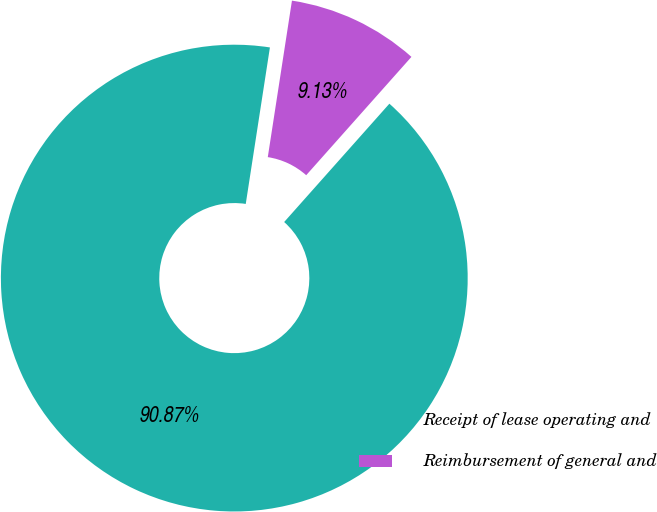<chart> <loc_0><loc_0><loc_500><loc_500><pie_chart><fcel>Receipt of lease operating and<fcel>Reimbursement of general and<nl><fcel>90.87%<fcel>9.13%<nl></chart> 